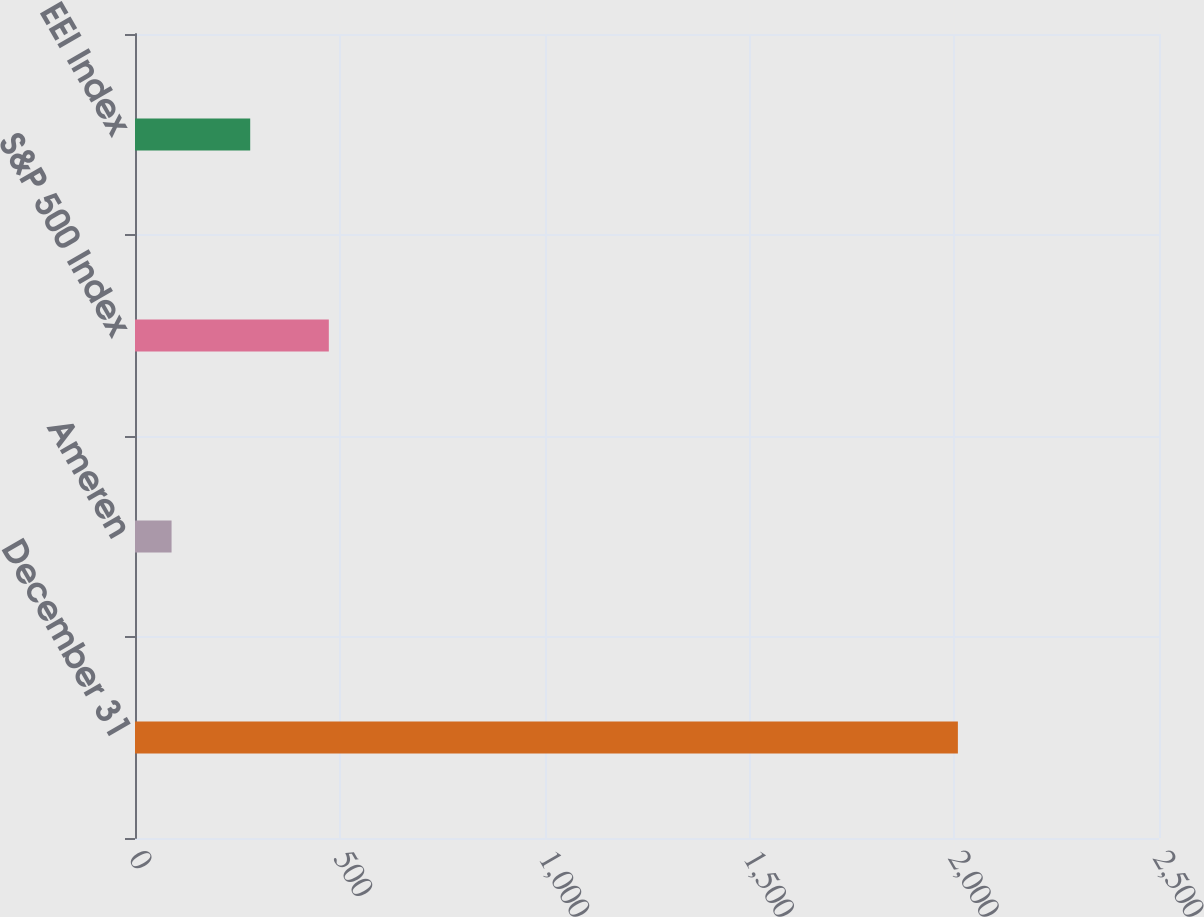<chart> <loc_0><loc_0><loc_500><loc_500><bar_chart><fcel>December 31<fcel>Ameren<fcel>S&P 500 Index<fcel>EEI Index<nl><fcel>2009<fcel>89.29<fcel>473.23<fcel>281.26<nl></chart> 